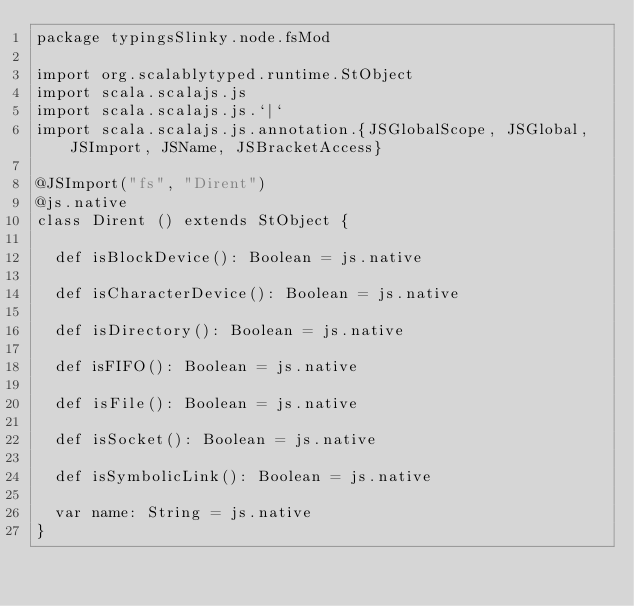Convert code to text. <code><loc_0><loc_0><loc_500><loc_500><_Scala_>package typingsSlinky.node.fsMod

import org.scalablytyped.runtime.StObject
import scala.scalajs.js
import scala.scalajs.js.`|`
import scala.scalajs.js.annotation.{JSGlobalScope, JSGlobal, JSImport, JSName, JSBracketAccess}

@JSImport("fs", "Dirent")
@js.native
class Dirent () extends StObject {
  
  def isBlockDevice(): Boolean = js.native
  
  def isCharacterDevice(): Boolean = js.native
  
  def isDirectory(): Boolean = js.native
  
  def isFIFO(): Boolean = js.native
  
  def isFile(): Boolean = js.native
  
  def isSocket(): Boolean = js.native
  
  def isSymbolicLink(): Boolean = js.native
  
  var name: String = js.native
}
</code> 